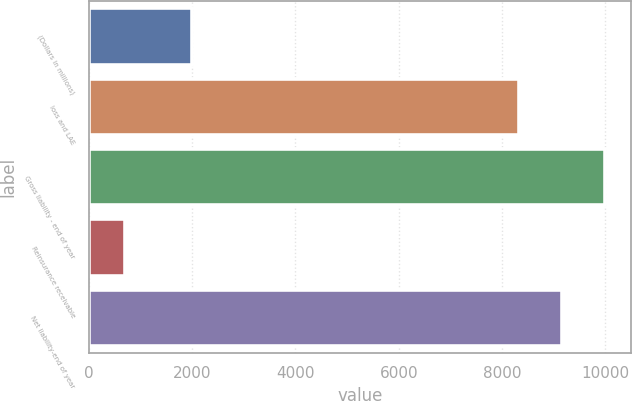Convert chart to OTSL. <chart><loc_0><loc_0><loc_500><loc_500><bar_chart><fcel>(Dollars in millions)<fcel>loss and LAE<fcel>Gross liability - end of year<fcel>Reinsurance receivable<fcel>Net liability-end of year<nl><fcel>2007<fcel>8324.7<fcel>9989.66<fcel>707.4<fcel>9157.18<nl></chart> 